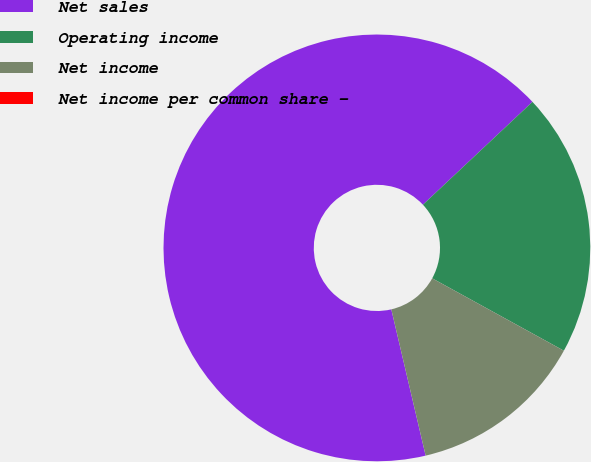Convert chart. <chart><loc_0><loc_0><loc_500><loc_500><pie_chart><fcel>Net sales<fcel>Operating income<fcel>Net income<fcel>Net income per common share -<nl><fcel>66.67%<fcel>20.0%<fcel>13.33%<fcel>0.0%<nl></chart> 